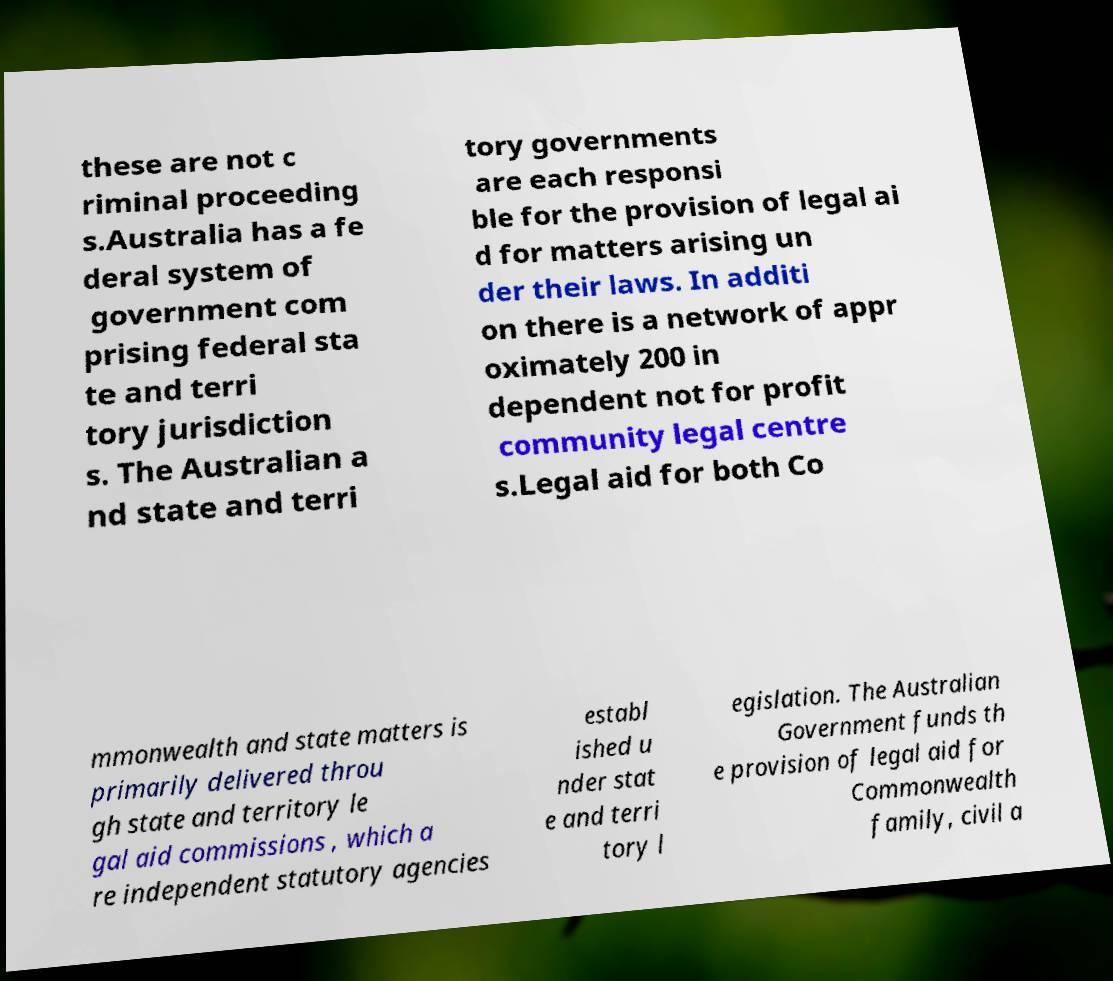Please identify and transcribe the text found in this image. these are not c riminal proceeding s.Australia has a fe deral system of government com prising federal sta te and terri tory jurisdiction s. The Australian a nd state and terri tory governments are each responsi ble for the provision of legal ai d for matters arising un der their laws. In additi on there is a network of appr oximately 200 in dependent not for profit community legal centre s.Legal aid for both Co mmonwealth and state matters is primarily delivered throu gh state and territory le gal aid commissions , which a re independent statutory agencies establ ished u nder stat e and terri tory l egislation. The Australian Government funds th e provision of legal aid for Commonwealth family, civil a 